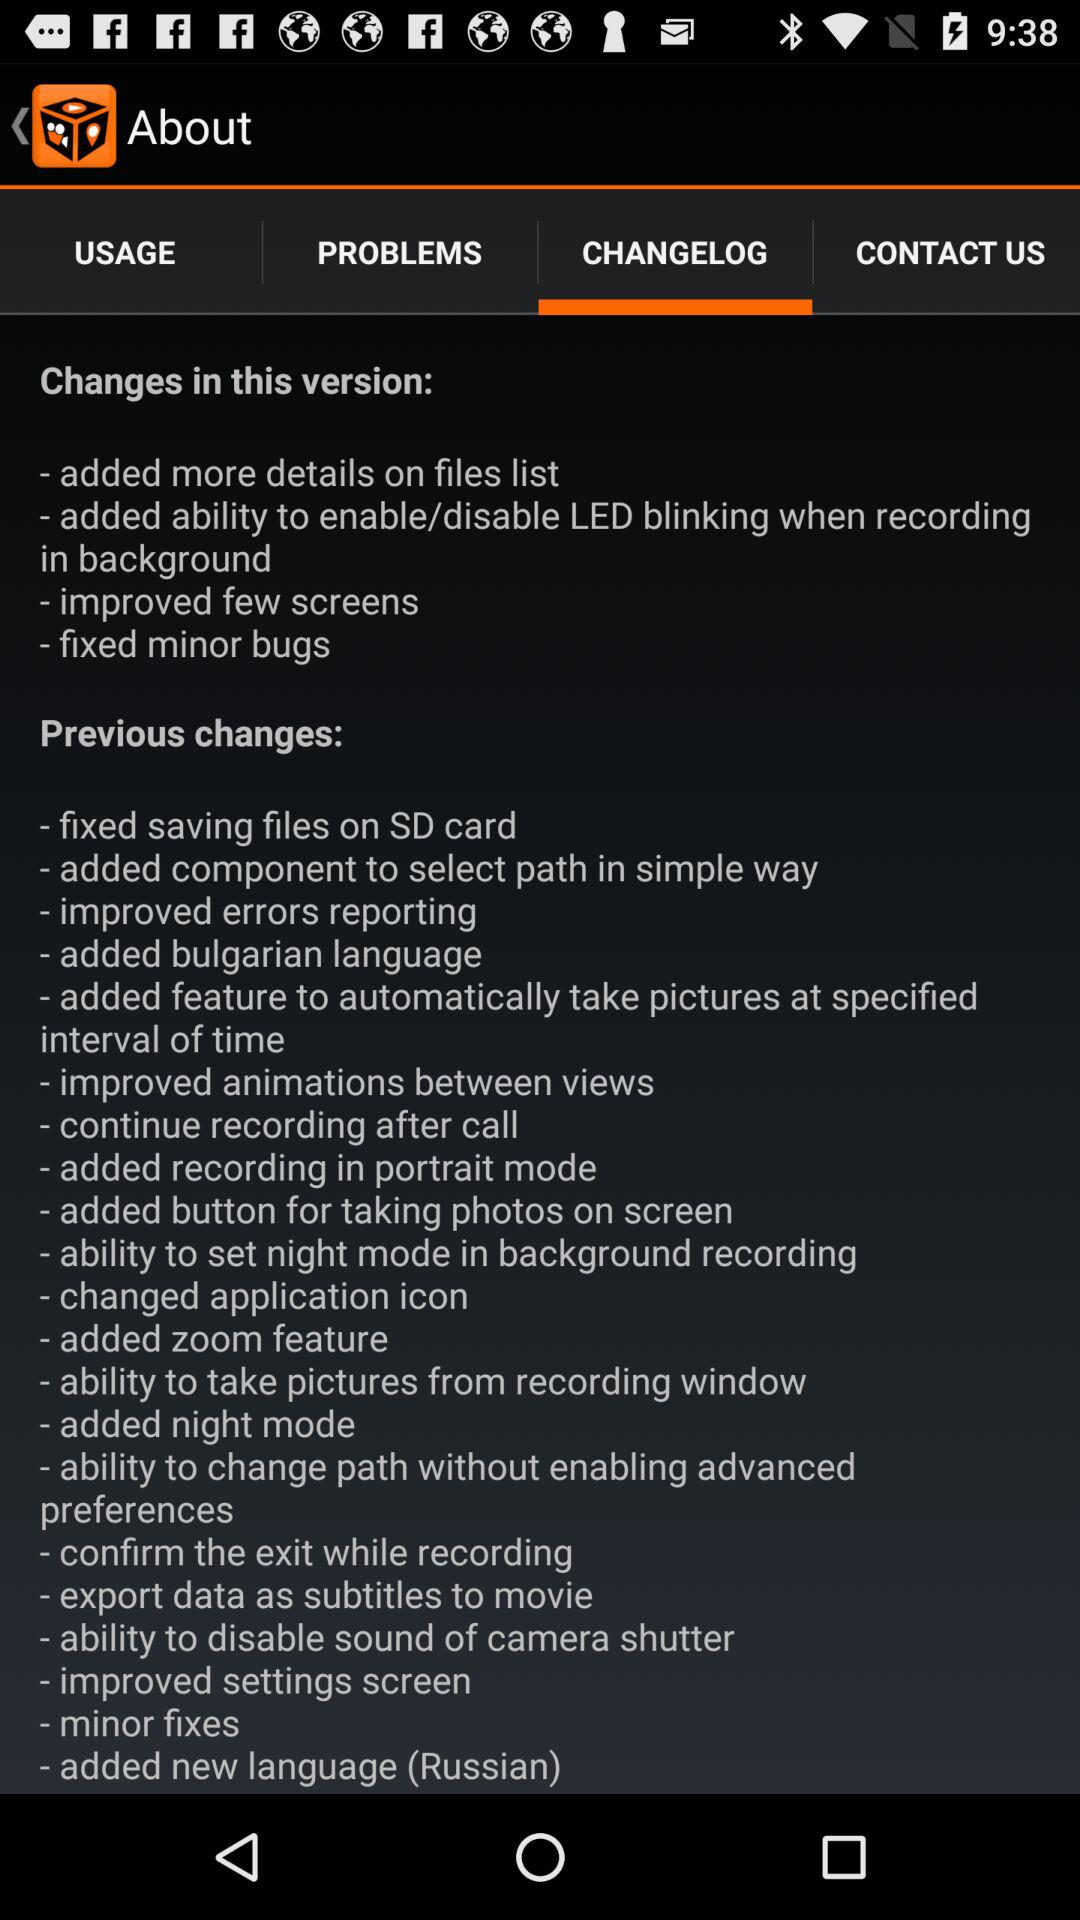Which option is selected in the "About" category? The selected option is "CHANGELOG". 